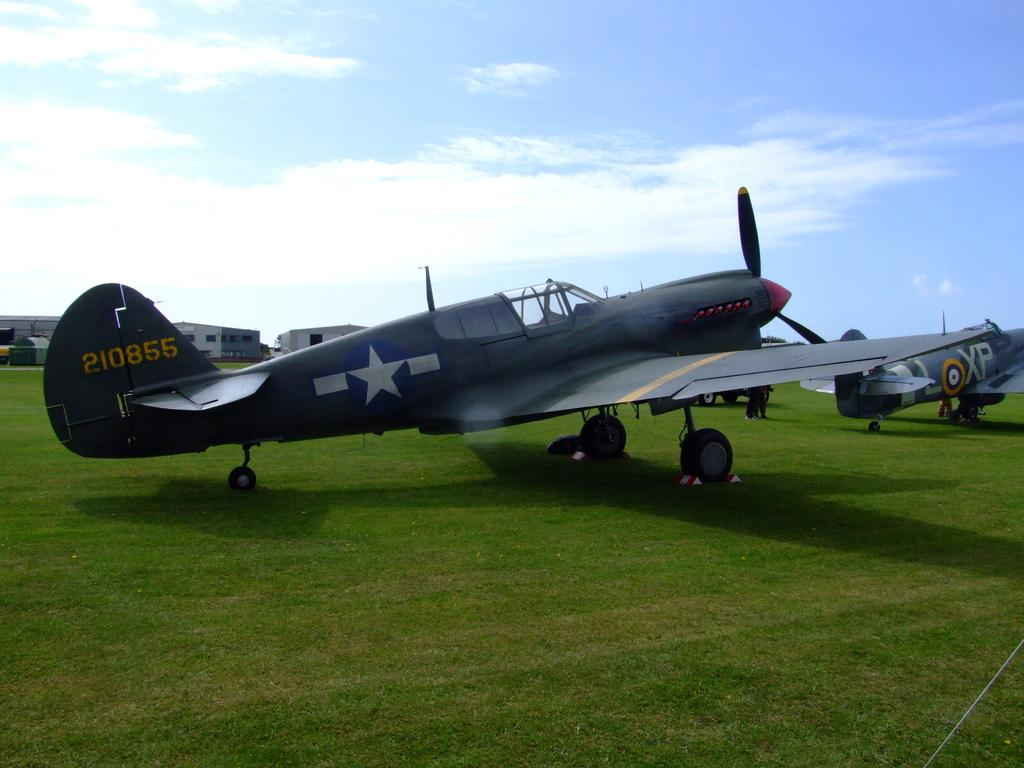<image>
Provide a brief description of the given image. Parked gray airplane with the numbers 210855 on it's plate. 